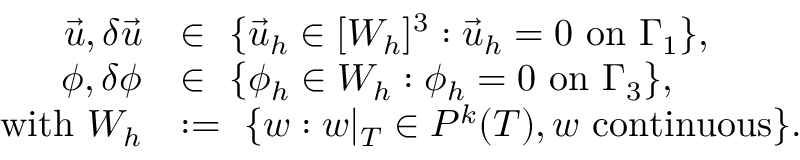<formula> <loc_0><loc_0><loc_500><loc_500>\begin{array} { r l } { \vec { u } , \delta \vec { u } } & { \in \ \{ \vec { u } _ { h } \in [ W _ { h } ] ^ { 3 } \colon \vec { u } _ { h } = 0 o n \Gamma _ { 1 } \} , } \\ { \phi , \delta \phi } & { \in \ \{ \phi _ { h } \in W _ { h } \colon \phi _ { h } = 0 o n \Gamma _ { 3 } \} , } \\ { w i t h W _ { h } } & { \colon = \ \{ w \colon w | _ { T } \in P ^ { k } ( T ) , w c o n t i n u o u s \} . } \end{array}</formula> 